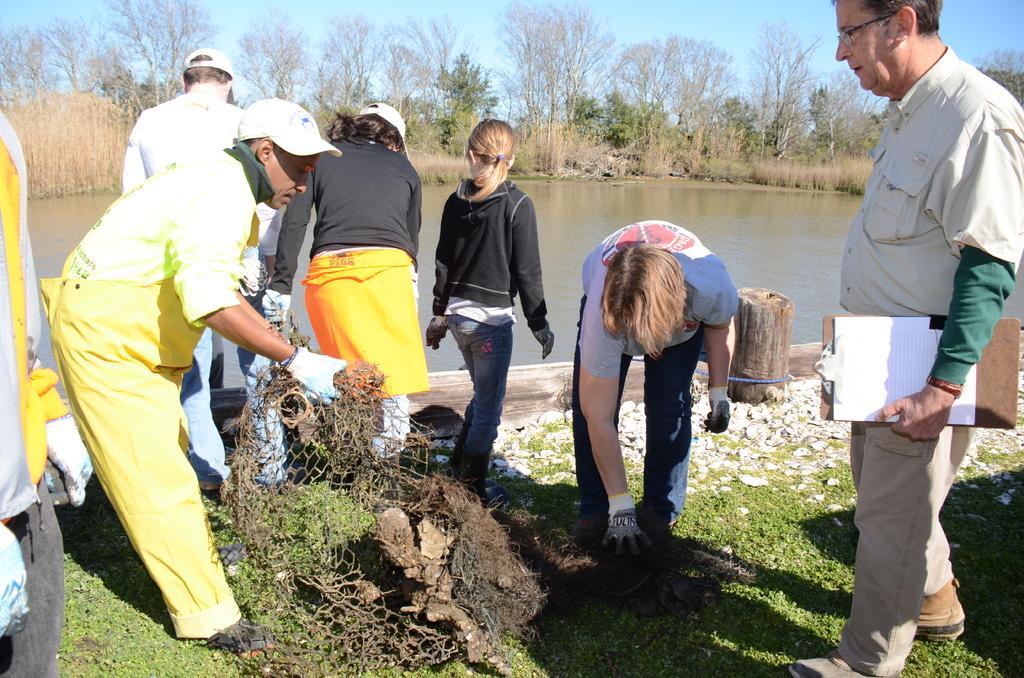Describe this image in one or two sentences. In this image, we can see persons wearing clothes. There is a person on the left side of the image holding a net with his hands. There is a lake in the middle of the image. There some trees at the top of the image. There is a grass on the ground. 